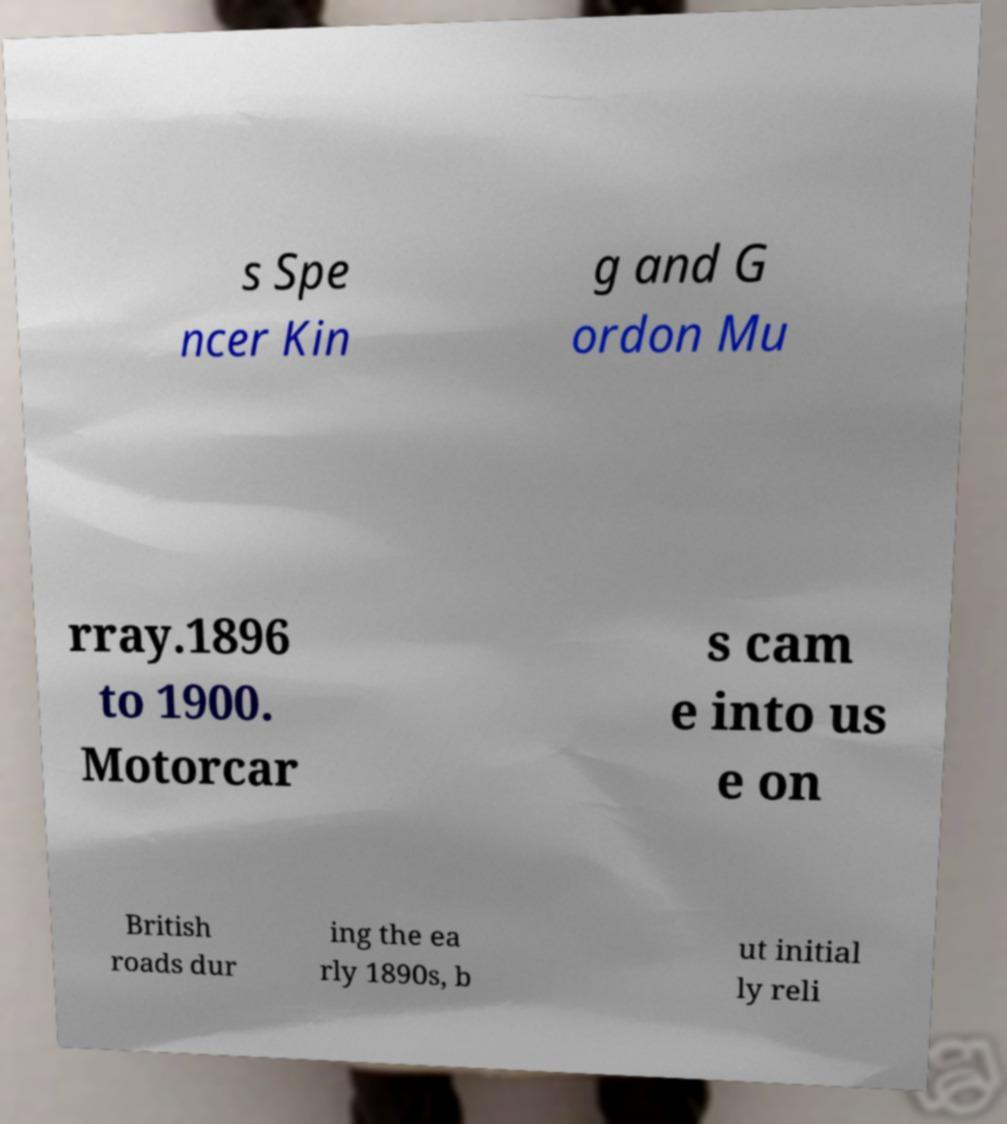What messages or text are displayed in this image? I need them in a readable, typed format. s Spe ncer Kin g and G ordon Mu rray.1896 to 1900. Motorcar s cam e into us e on British roads dur ing the ea rly 1890s, b ut initial ly reli 